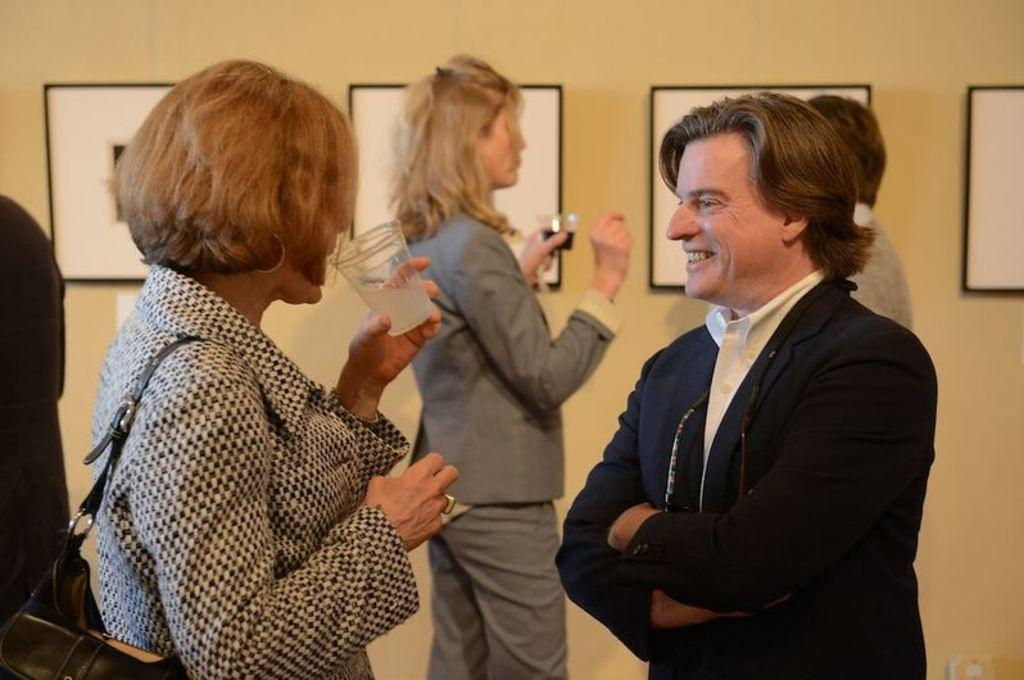Who or what can be seen in the image? There are people in the image. What are some of the people holding? Some people are holding glasses. What can be seen on the wall in the image? There is a wall with posters in the image. What type of cable can be seen hanging from the ceiling in the image? There is no cable hanging from the ceiling in the image. 